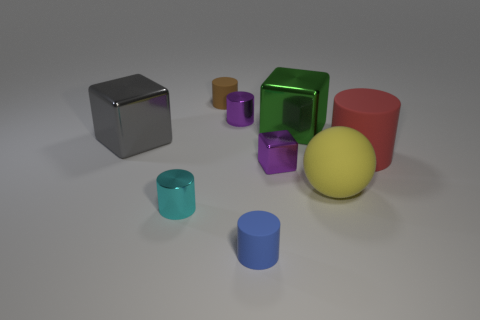Subtract all gray balls. Subtract all yellow blocks. How many balls are left? 1 Subtract all cylinders. How many objects are left? 4 Add 7 big gray objects. How many big gray objects are left? 8 Add 6 tiny cyan objects. How many tiny cyan objects exist? 7 Subtract 0 brown balls. How many objects are left? 9 Subtract all green metal objects. Subtract all yellow objects. How many objects are left? 7 